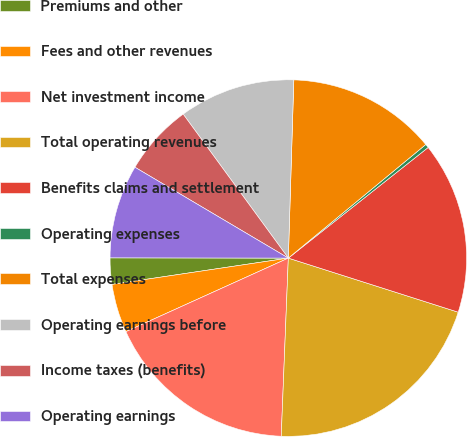<chart> <loc_0><loc_0><loc_500><loc_500><pie_chart><fcel>Premiums and other<fcel>Fees and other revenues<fcel>Net investment income<fcel>Total operating revenues<fcel>Benefits claims and settlement<fcel>Operating expenses<fcel>Total expenses<fcel>Operating earnings before<fcel>Income taxes (benefits)<fcel>Operating earnings<nl><fcel>2.38%<fcel>4.41%<fcel>17.6%<fcel>20.73%<fcel>15.56%<fcel>0.34%<fcel>13.52%<fcel>10.53%<fcel>6.45%<fcel>8.49%<nl></chart> 